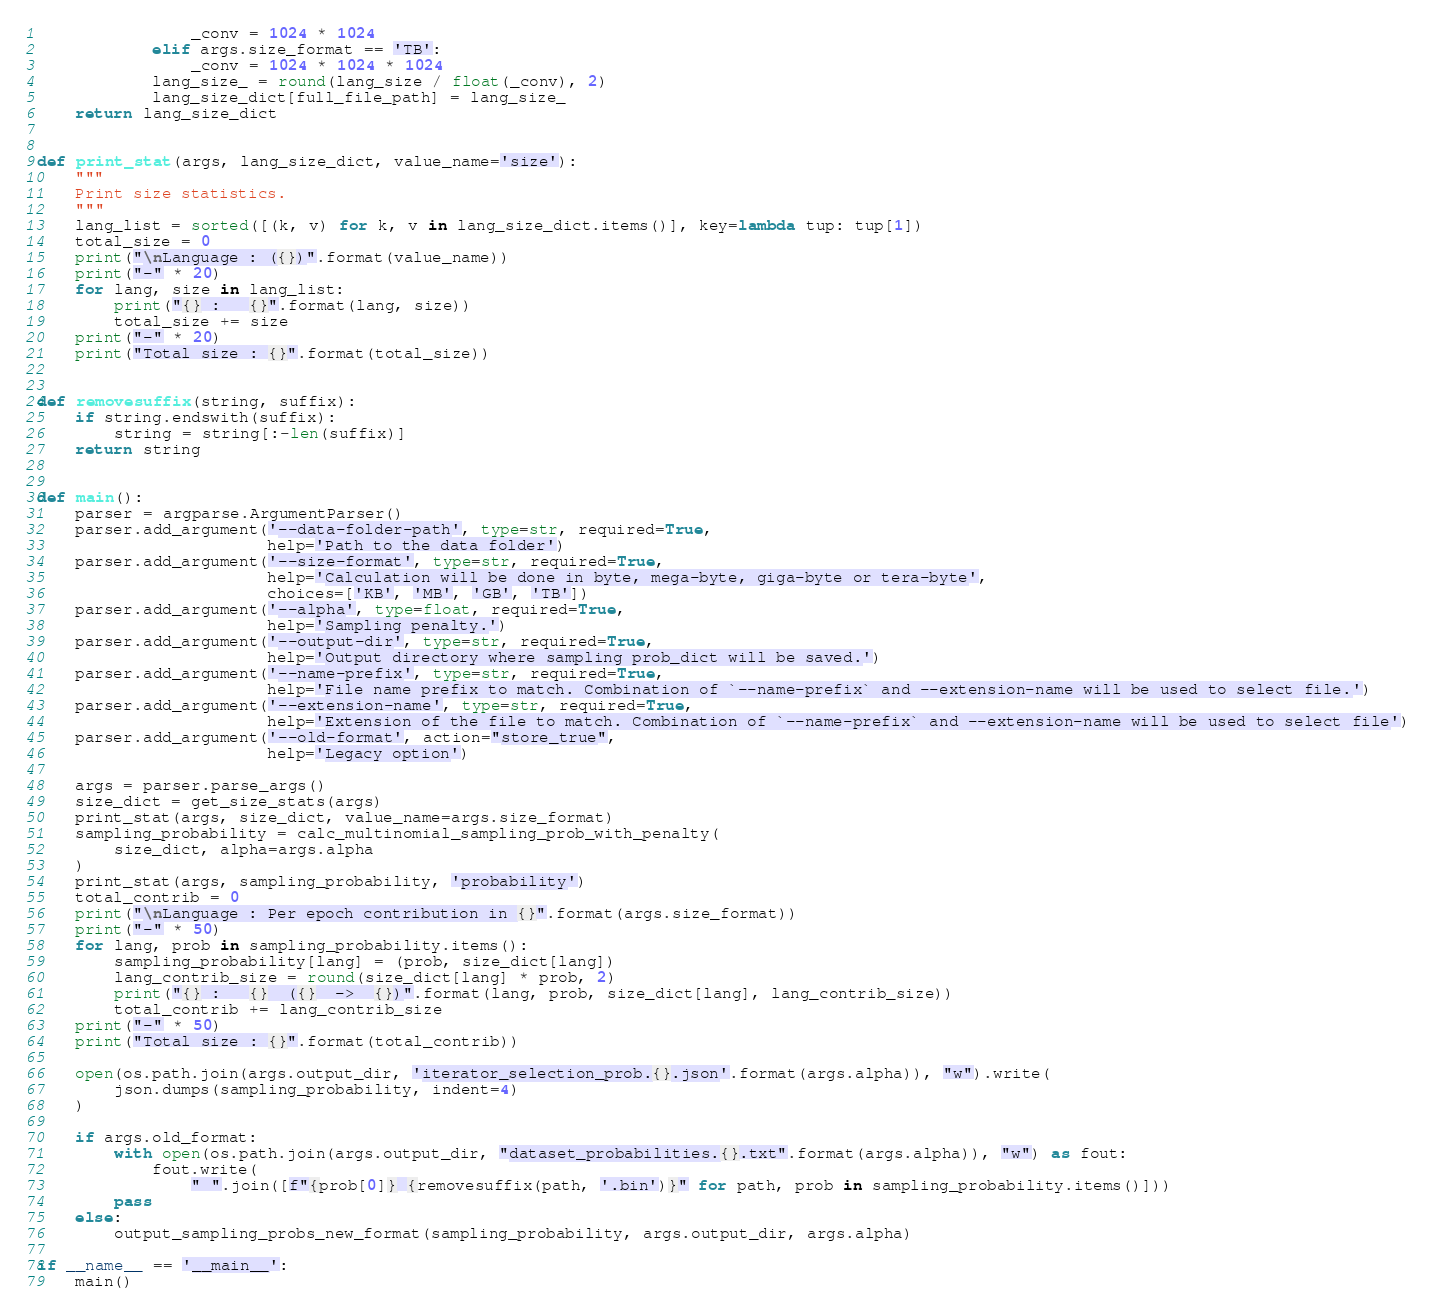Convert code to text. <code><loc_0><loc_0><loc_500><loc_500><_Python_>                _conv = 1024 * 1024
            elif args.size_format == 'TB':
                _conv = 1024 * 1024 * 1024
            lang_size_ = round(lang_size / float(_conv), 2)
            lang_size_dict[full_file_path] = lang_size_
    return lang_size_dict


def print_stat(args, lang_size_dict, value_name='size'):
    """
    Print size statistics.
    """
    lang_list = sorted([(k, v) for k, v in lang_size_dict.items()], key=lambda tup: tup[1])
    total_size = 0
    print("\nLanguage : ({})".format(value_name))
    print("-" * 20)
    for lang, size in lang_list:
        print("{} :   {}".format(lang, size))
        total_size += size
    print("-" * 20)
    print("Total size : {}".format(total_size))


def removesuffix(string, suffix):
    if string.endswith(suffix):
        string = string[:-len(suffix)]
    return string


def main():
    parser = argparse.ArgumentParser()
    parser.add_argument('--data-folder-path', type=str, required=True,
                        help='Path to the data folder')
    parser.add_argument('--size-format', type=str, required=True,
                        help='Calculation will be done in byte, mega-byte, giga-byte or tera-byte',
                        choices=['KB', 'MB', 'GB', 'TB'])
    parser.add_argument('--alpha', type=float, required=True,
                        help='Sampling penalty.')
    parser.add_argument('--output-dir', type=str, required=True,
                        help='Output directory where sampling prob_dict will be saved.')
    parser.add_argument('--name-prefix', type=str, required=True,
                        help='File name prefix to match. Combination of `--name-prefix` and --extension-name will be used to select file.')
    parser.add_argument('--extension-name', type=str, required=True,
                        help='Extension of the file to match. Combination of `--name-prefix` and --extension-name will be used to select file')
    parser.add_argument('--old-format', action="store_true",
                        help='Legacy option')

    args = parser.parse_args()
    size_dict = get_size_stats(args)
    print_stat(args, size_dict, value_name=args.size_format)
    sampling_probability = calc_multinomial_sampling_prob_with_penalty(
        size_dict, alpha=args.alpha
    )
    print_stat(args, sampling_probability, 'probability')
    total_contrib = 0
    print("\nLanguage : Per epoch contribution in {}".format(args.size_format))
    print("-" * 50)
    for lang, prob in sampling_probability.items():
        sampling_probability[lang] = (prob, size_dict[lang])
        lang_contrib_size = round(size_dict[lang] * prob, 2)
        print("{} :   {}  ({}  ->  {})".format(lang, prob, size_dict[lang], lang_contrib_size))
        total_contrib += lang_contrib_size
    print("-" * 50)
    print("Total size : {}".format(total_contrib))

    open(os.path.join(args.output_dir, 'iterator_selection_prob.{}.json'.format(args.alpha)), "w").write(
        json.dumps(sampling_probability, indent=4)
    )

    if args.old_format:
        with open(os.path.join(args.output_dir, "dataset_probabilities.{}.txt".format(args.alpha)), "w") as fout:
            fout.write(
                " ".join([f"{prob[0]} {removesuffix(path, '.bin')}" for path, prob in sampling_probability.items()]))
        pass
    else:
        output_sampling_probs_new_format(sampling_probability, args.output_dir, args.alpha)

if __name__ == '__main__':
    main()
</code> 